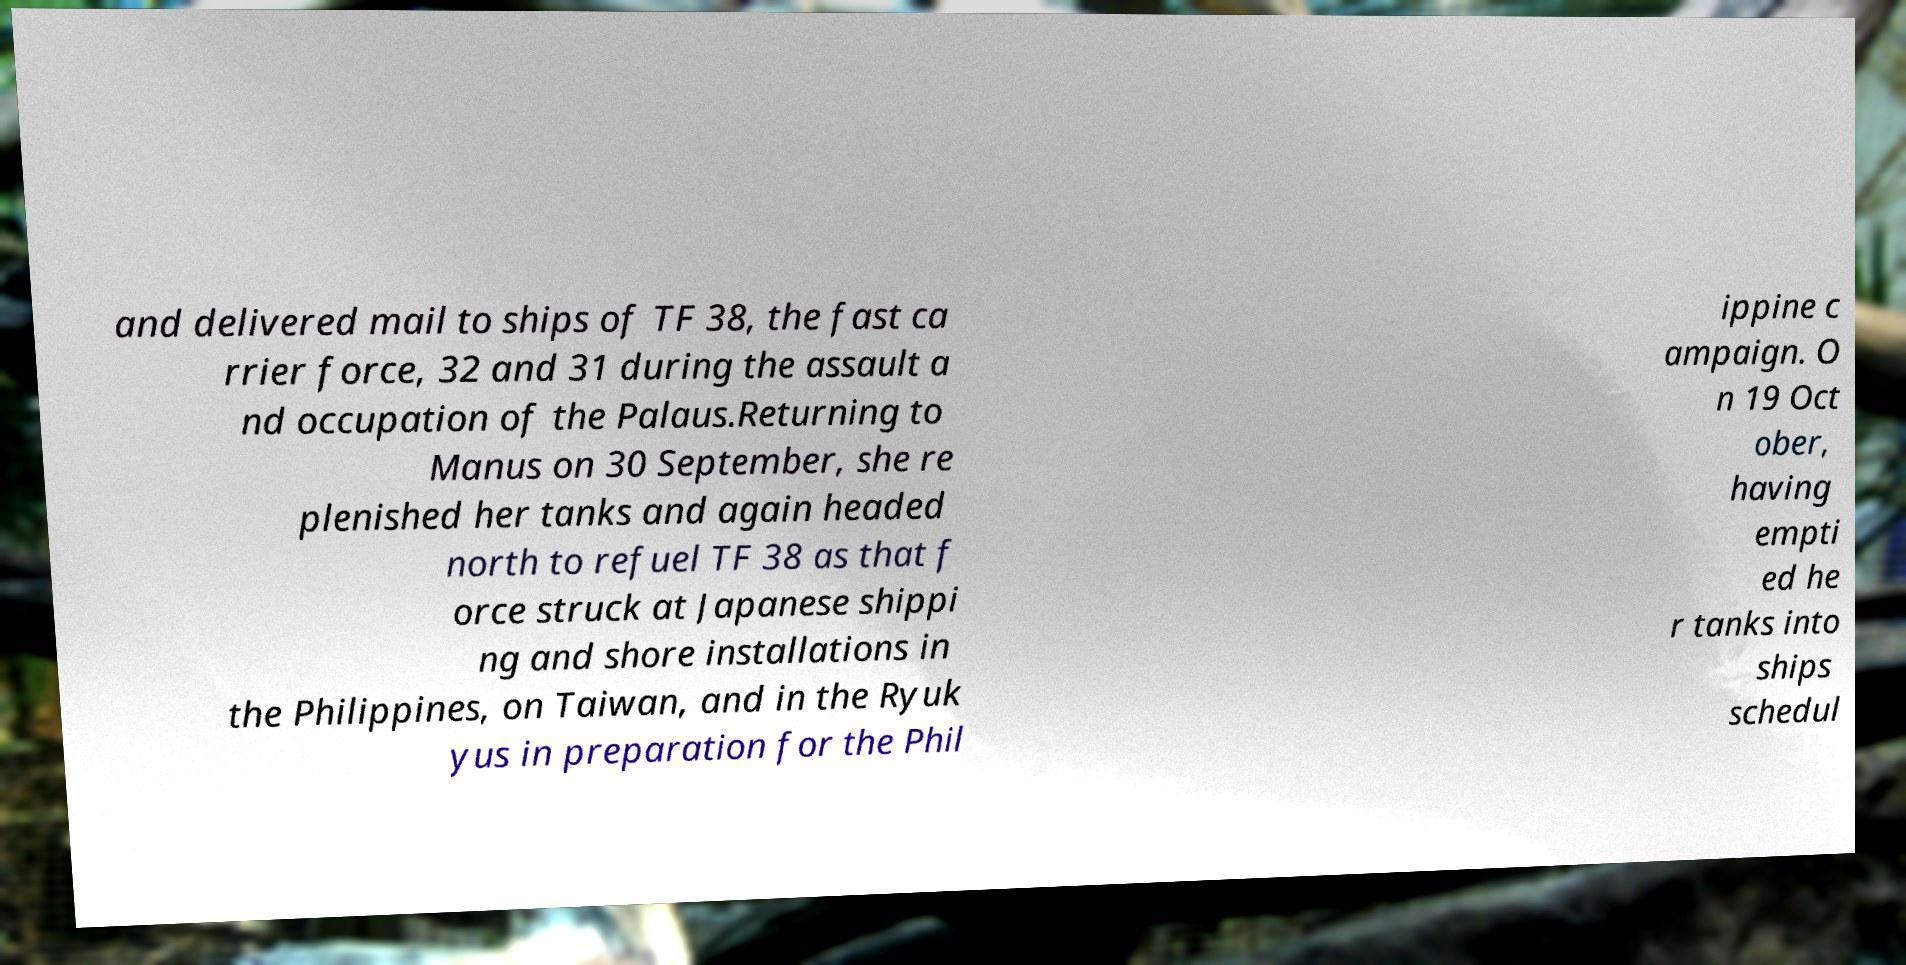Can you read and provide the text displayed in the image?This photo seems to have some interesting text. Can you extract and type it out for me? and delivered mail to ships of TF 38, the fast ca rrier force, 32 and 31 during the assault a nd occupation of the Palaus.Returning to Manus on 30 September, she re plenished her tanks and again headed north to refuel TF 38 as that f orce struck at Japanese shippi ng and shore installations in the Philippines, on Taiwan, and in the Ryuk yus in preparation for the Phil ippine c ampaign. O n 19 Oct ober, having empti ed he r tanks into ships schedul 